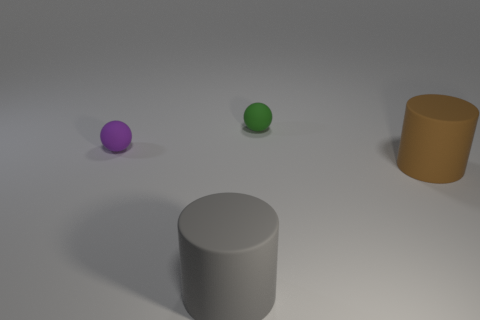Do the rubber sphere on the left side of the gray cylinder and the brown cylinder have the same size?
Provide a succinct answer. No. What color is the matte thing that is both in front of the purple object and right of the gray rubber object?
Your answer should be very brief. Brown. How many objects are brown rubber cylinders or large rubber things that are to the left of the green sphere?
Make the answer very short. 2. There is a tiny ball to the right of the tiny matte sphere that is in front of the matte ball that is behind the purple matte ball; what is its material?
Give a very brief answer. Rubber. Are there any other things that have the same material as the big brown cylinder?
Your answer should be very brief. Yes. What number of yellow things are small matte balls or big things?
Provide a short and direct response. 0. Is the number of small cylinders the same as the number of large gray things?
Your response must be concise. No. How many other objects are there of the same shape as the green rubber object?
Keep it short and to the point. 1. Are the big gray cylinder and the tiny green ball made of the same material?
Your response must be concise. Yes. There is a thing that is both in front of the green rubber sphere and on the right side of the gray cylinder; what material is it?
Your answer should be very brief. Rubber. 